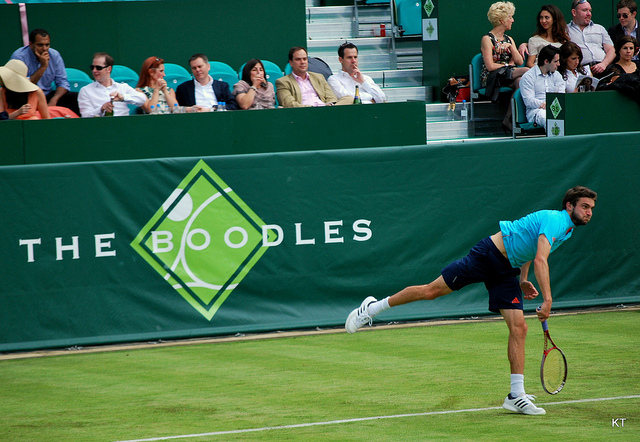<image>What is the speed of the serve? It is unknown what the speed of the serve is. It can be 30 mph or 15 mph. What is the speed of the serve? I don't know what the speed of the serve is. It can be 30 mph or 15 mph, but it is definitely fast. 